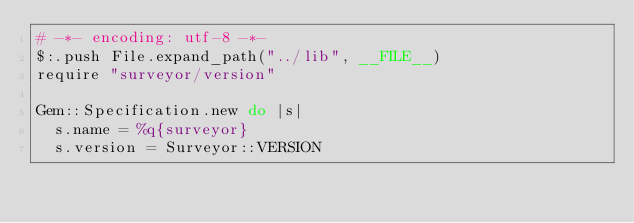Convert code to text. <code><loc_0><loc_0><loc_500><loc_500><_Ruby_># -*- encoding: utf-8 -*-
$:.push File.expand_path("../lib", __FILE__)
require "surveyor/version"

Gem::Specification.new do |s|
  s.name = %q{surveyor}
  s.version = Surveyor::VERSION
</code> 